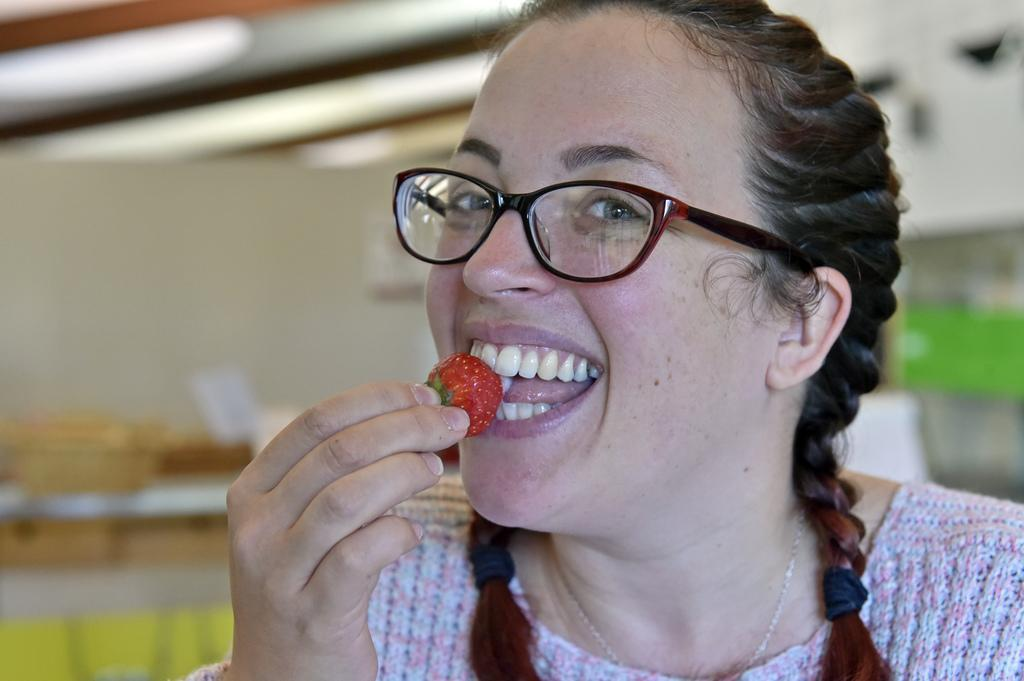Who or what is the main subject in the image? There is a person in the image. What is the person doing in the image? The person is eating a strawberry. What can be seen in the background of the image? The background of the image is blurred. Are there any other elements visible in the image besides the person and the strawberry? Yes, there are lights visible in the image. How many metal boats are visible in the image? There are no metal boats present in the image. What type of number is written on the person's shirt in the image? The person's shirt does not have any numbers visible in the image. 